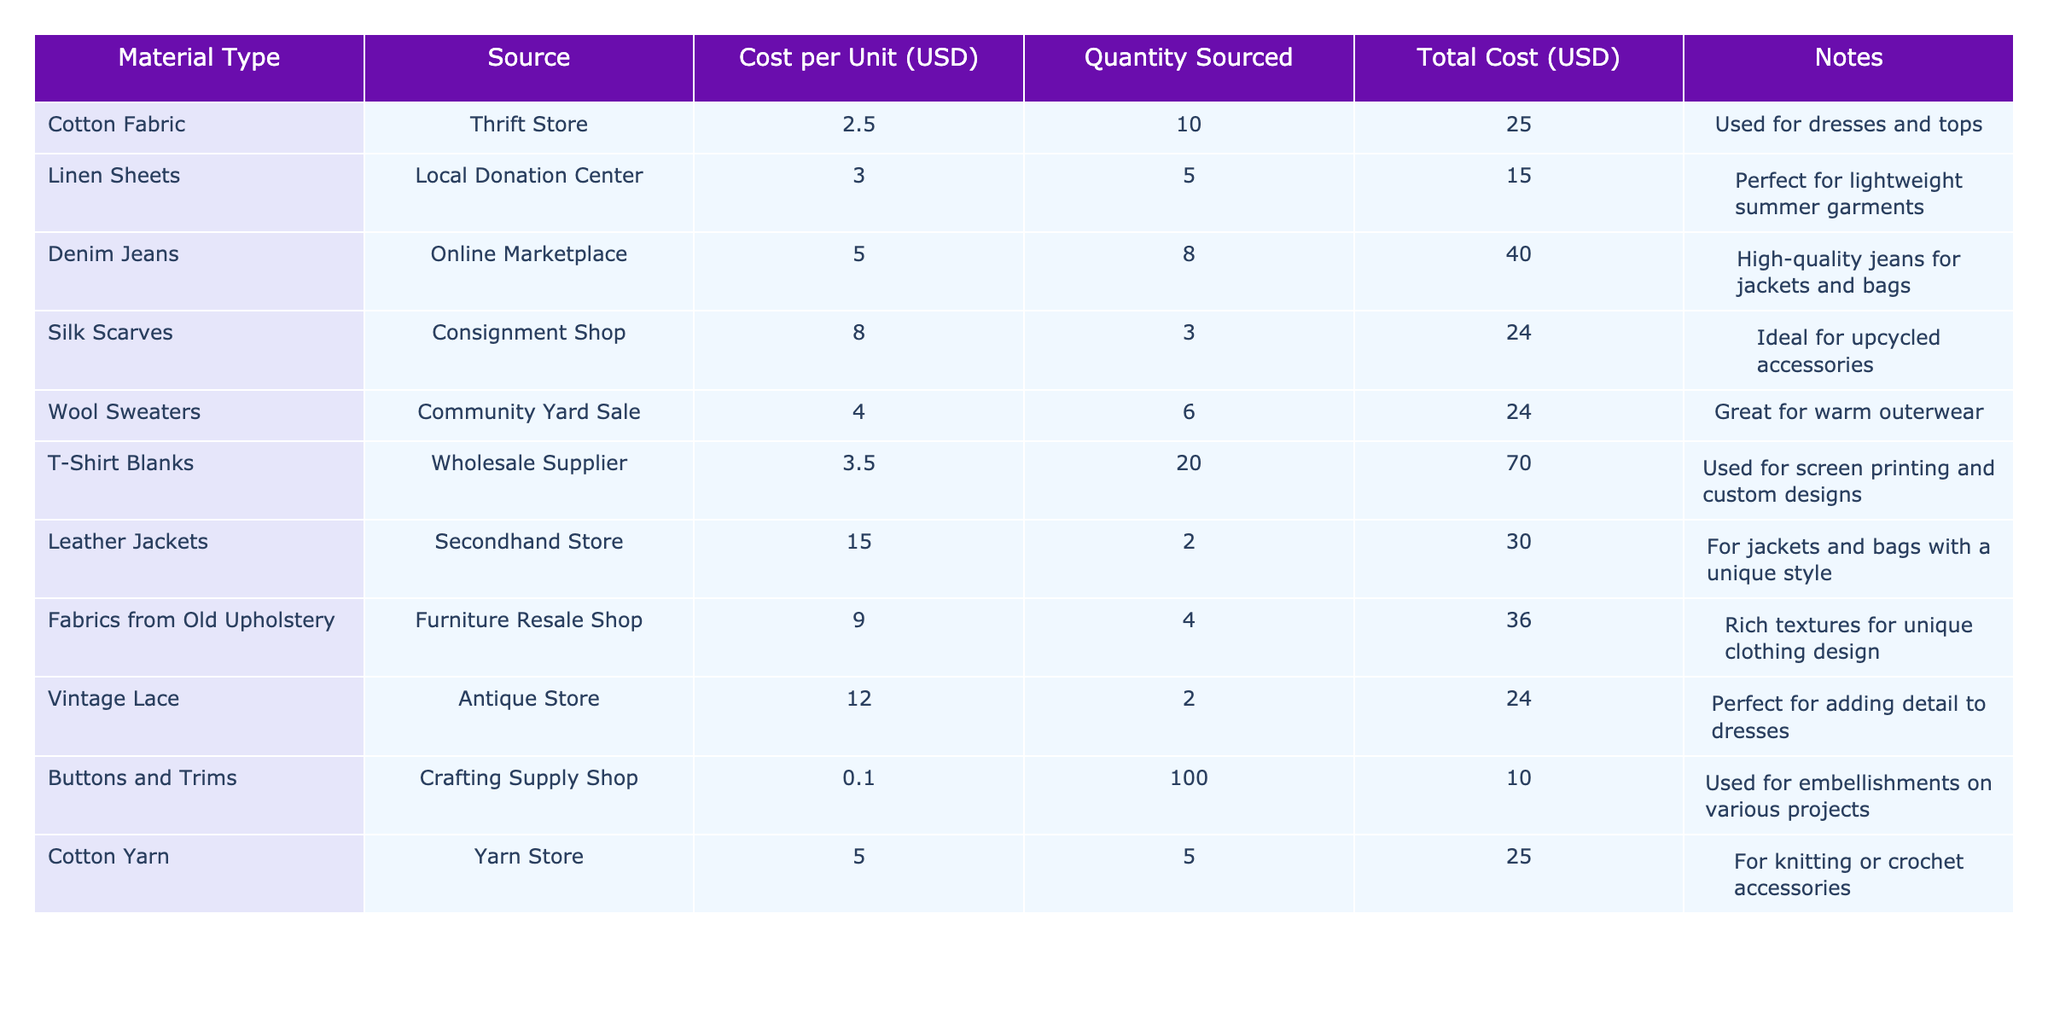What is the total cost for the Silk Scarves? The total cost for the Silk Scarves is given directly in the table under the "Total Cost (USD)" column for that material. The value is listed as 24.00.
Answer: 24.00 How many units of Denim Jeans were sourced? The quantity sourced for Denim Jeans is found in the "Quantity Sourced" column of the table. It shows a value of 8.
Answer: 8 What is the average cost per unit for all materials listed? To find the average cost per unit, first sum all costs per unit: 2.50 + 3.00 + 5.00 + 8.00 + 4.00 + 3.50 + 15.00 + 9.00 + 12.00 + 0.10 + 5.00 = 62.10. There are 11 materials, so divide the sum by 11 to get 62.10 / 11 = 5.64.
Answer: 5.64 Which material has the highest total cost? The highest total cost can be identified by comparing the "Total Cost (USD)" values across all materials. After reviewing the data, Denim Jeans have the highest total cost at 40.00.
Answer: Denim Jeans Is the cost per unit for Cotton Fabric less than that for Leather Jackets? Compare the "Cost per Unit (USD)" values for Cotton Fabric (2.50) and Leather Jackets (15.00). Since 2.50 is indeed less than 15.00, the statement is true.
Answer: Yes What is the total cost of all materials sourced? To find the total cost of all materials, sum the "Total Cost (USD)" values: 25.00 + 15.00 + 40.00 + 24.00 + 24.00 + 70.00 + 30.00 + 36.00 + 24.00 + 10.00 + 25.00 =  329.00.
Answer: 329.00 What percentage of the total cost does T-Shirt Blanks represent? First, find the cost of T-Shirt Blanks, which is 70.00. Then, divide this by the total cost (329.00) and multiply by 100: (70.00 / 329.00) * 100 = 21.24%.
Answer: 21.24% How many more units of T-Shirt Blanks were sourced than Silk Scarves? The quantity sourced for T-Shirt Blanks is 20 and for Silk Scarves is 3. Subtract the two quantities: 20 - 3 = 17.
Answer: 17 What is the total cost of materials sourced from the Thrift Store? According to the table, there is only one material sourced from the Thrift Store, which is Cotton Fabric, with a total cost of 25.00.
Answer: 25.00 Are there more sources of materials with a cost of 5.00 or less compared to those with a cost over 5.00? Count the materials with costs of 5.00 or less: Cotton Fabric, Linen Sheets, and Buttons and Trims (3 materials). Then count those over 5.00: Denim Jeans, Silk Scarves, Wool Sweaters, T-Shirt Blanks, Leather Jackets, Fabrics from Old Upholstery, Vintage Lace, and Cotton Yarn (8 materials). Thus, there are more materials with a cost over 5.00, making the statement true.
Answer: Yes 